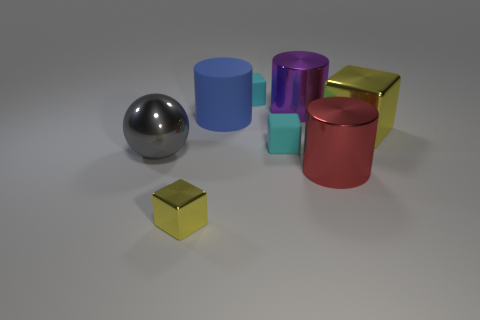There is a gray sphere that is the same material as the purple cylinder; what is its size?
Give a very brief answer. Large. Are there more things on the right side of the large red thing than big things?
Ensure brevity in your answer.  No. Does the big gray thing have the same shape as the tiny cyan rubber thing in front of the big purple metal cylinder?
Offer a terse response. No. How many tiny objects are either red metal cylinders or balls?
Provide a succinct answer. 0. What is the size of the other shiny cube that is the same color as the large shiny block?
Your response must be concise. Small. There is a small rubber thing that is behind the cube that is on the right side of the big purple metal cylinder; what is its color?
Provide a short and direct response. Cyan. Is the big block made of the same material as the yellow cube that is in front of the gray metal sphere?
Provide a succinct answer. Yes. There is a large object to the right of the big red thing; what is it made of?
Make the answer very short. Metal. Is the number of yellow metallic objects on the left side of the shiny ball the same as the number of big gray balls?
Provide a succinct answer. No. There is a cyan object that is in front of the blue rubber object left of the big yellow shiny block; what is its material?
Your response must be concise. Rubber. 